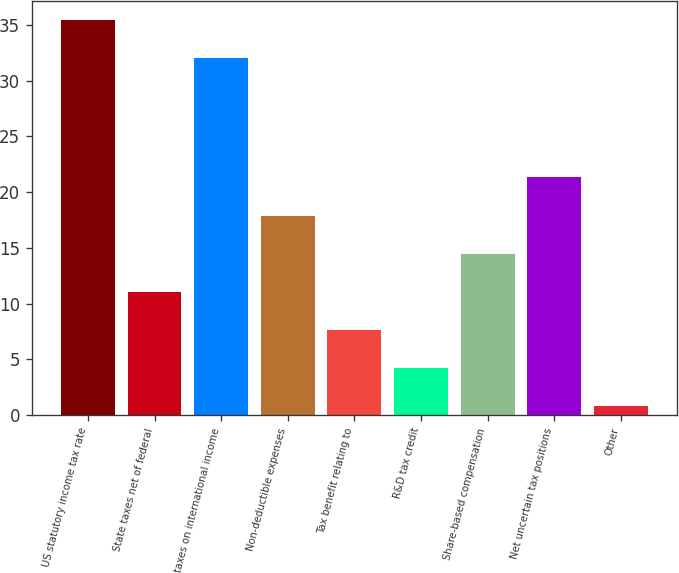Convert chart to OTSL. <chart><loc_0><loc_0><loc_500><loc_500><bar_chart><fcel>US statutory income tax rate<fcel>State taxes net of federal<fcel>taxes on international income<fcel>Non-deductible expenses<fcel>Tax benefit relating to<fcel>R&D tax credit<fcel>Share-based compensation<fcel>Net uncertain tax positions<fcel>Other<nl><fcel>35.42<fcel>11.06<fcel>32<fcel>17.9<fcel>7.64<fcel>4.22<fcel>14.48<fcel>21.32<fcel>0.8<nl></chart> 